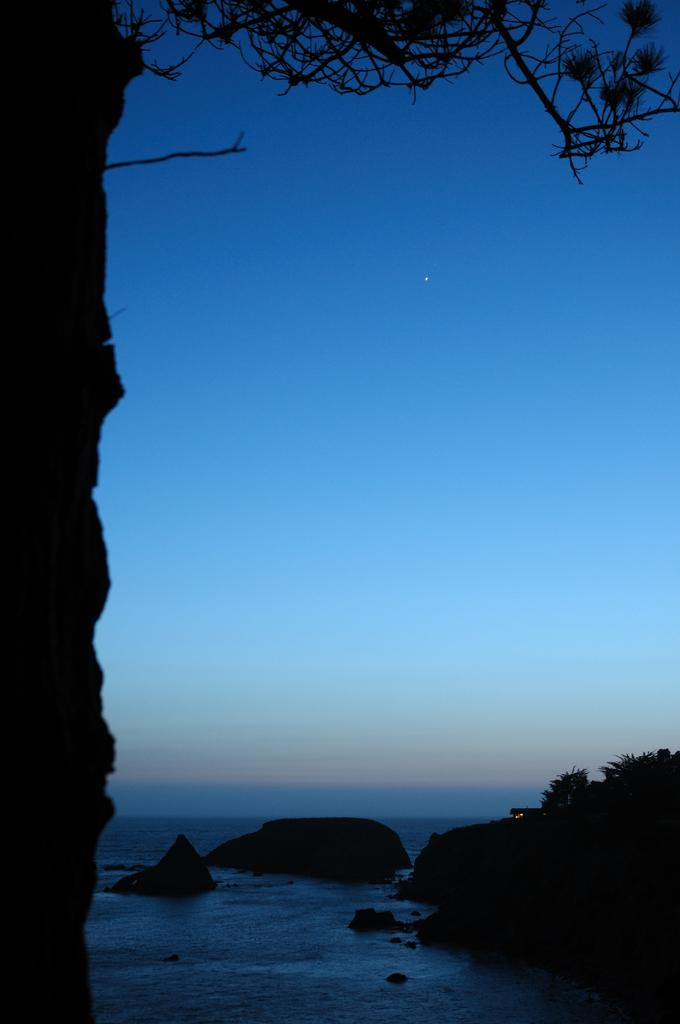What type of vegetation is present in the image? There is a tree and plants in the image. What other natural elements can be seen in the image? There are rocks in the image. What is visible in the background of the image? The sky is visible in the image. What type of store can be seen in the image? There is no store present in the image; it features natural elements such as a tree, plants, rocks, and the sky. Can you tell me how many planes are visible in the image? There are no planes present in the image. 